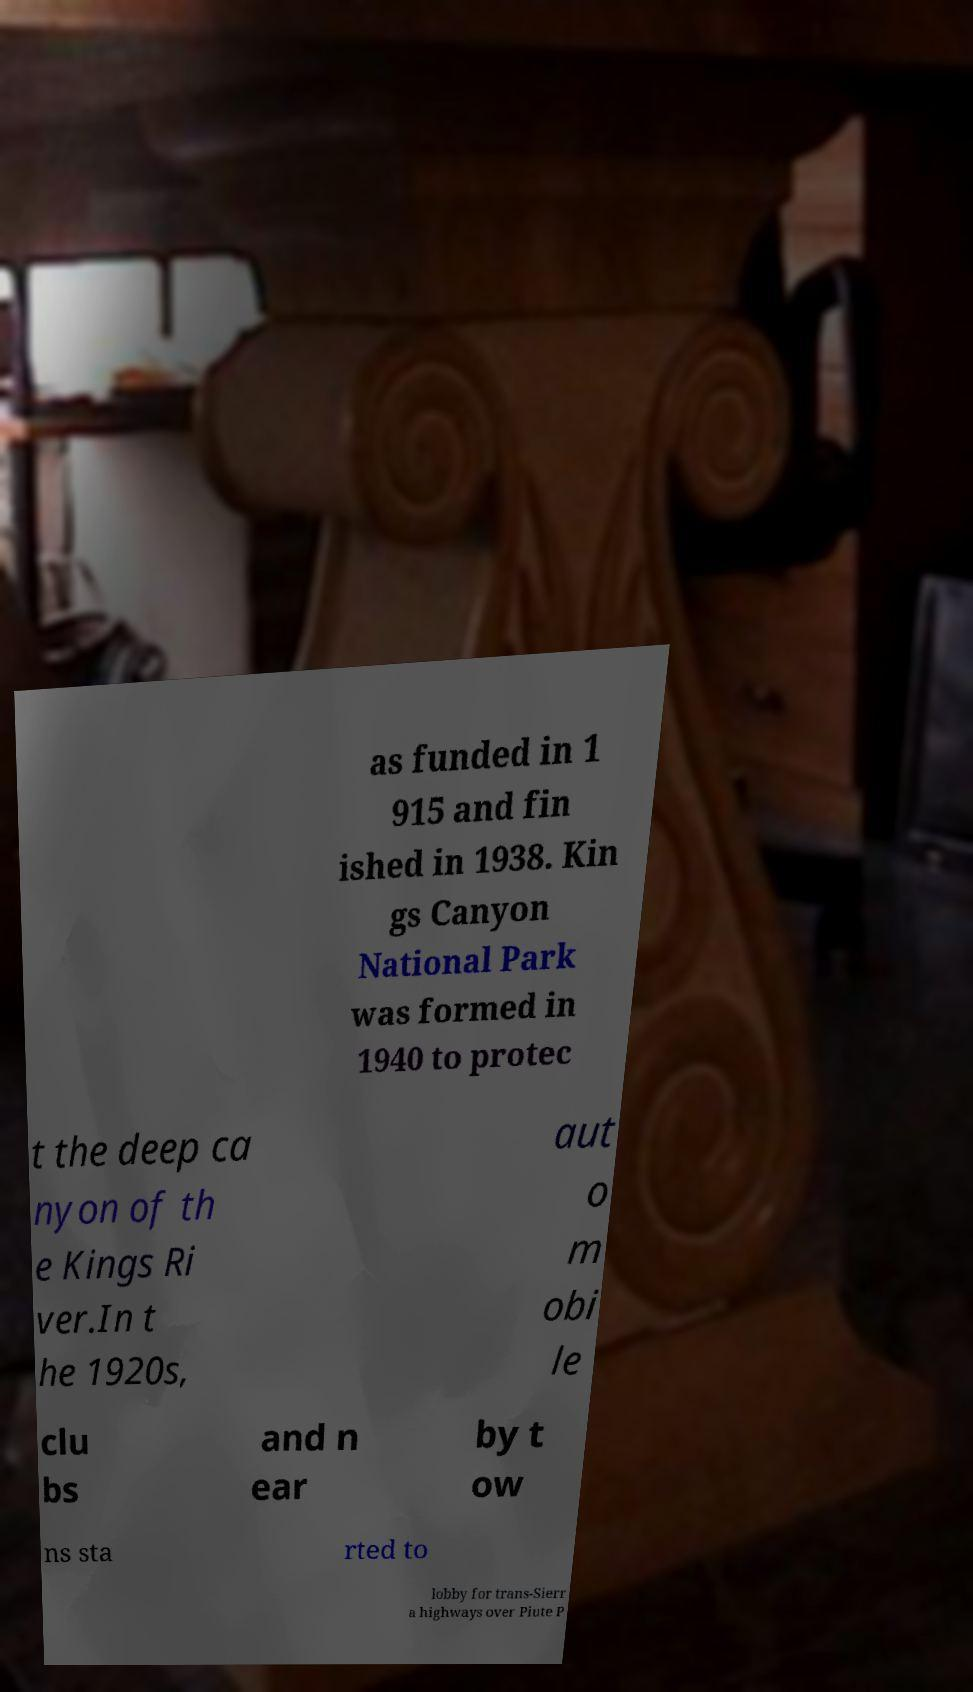Can you read and provide the text displayed in the image?This photo seems to have some interesting text. Can you extract and type it out for me? as funded in 1 915 and fin ished in 1938. Kin gs Canyon National Park was formed in 1940 to protec t the deep ca nyon of th e Kings Ri ver.In t he 1920s, aut o m obi le clu bs and n ear by t ow ns sta rted to lobby for trans-Sierr a highways over Piute P 